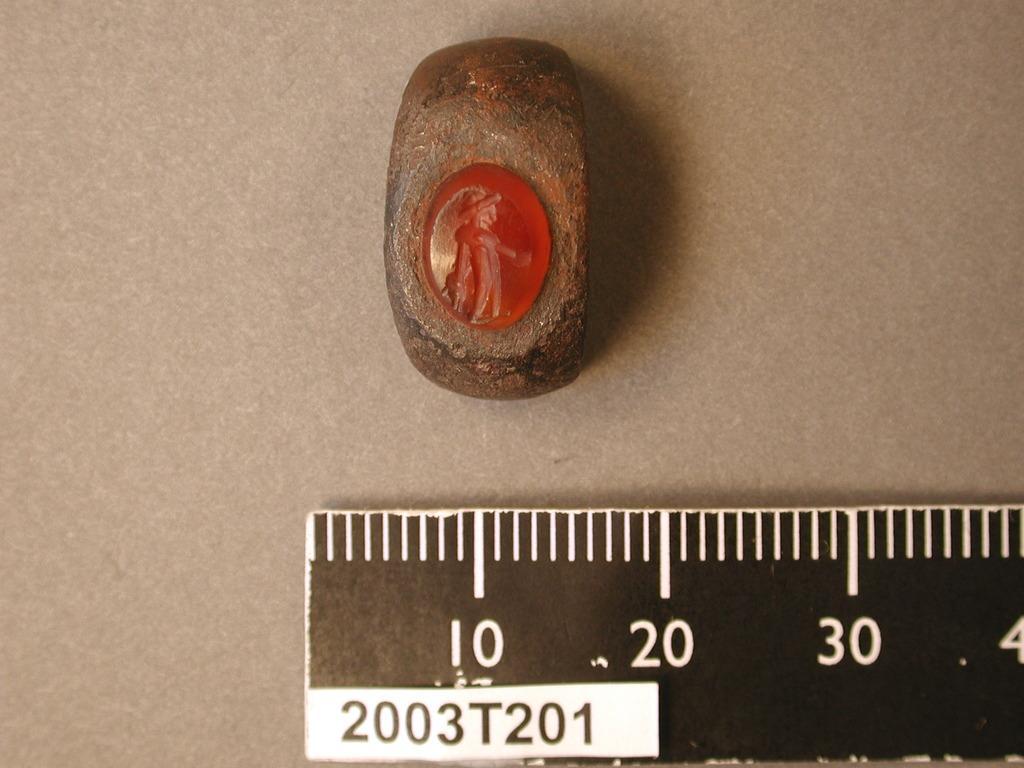Could you give a brief overview of what you see in this image? In this image we can see a scale and some object on the surface. 